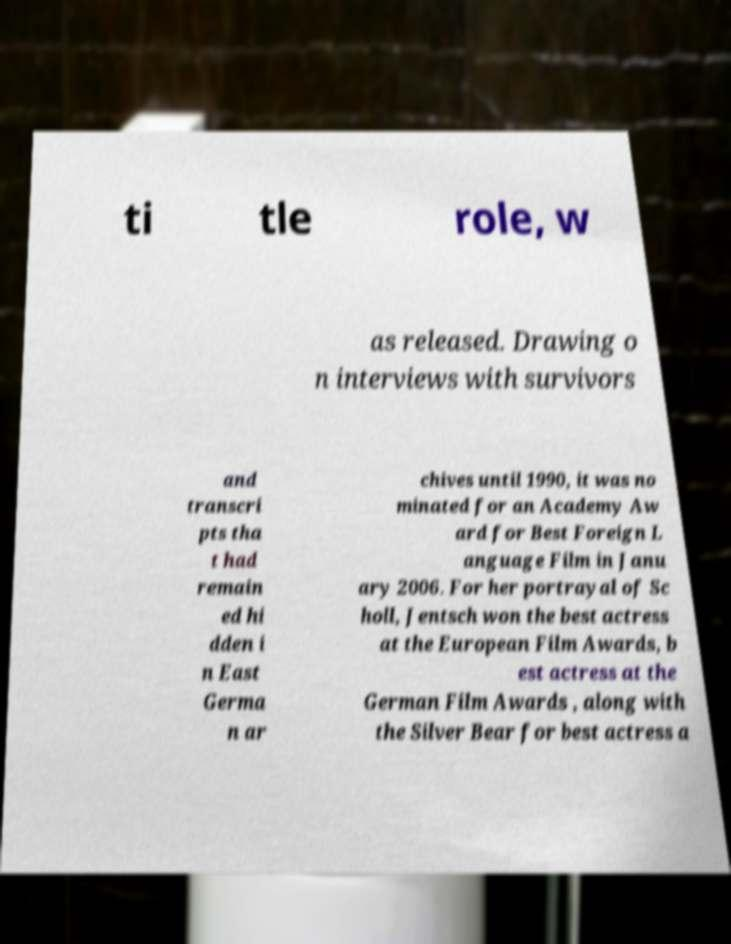Please identify and transcribe the text found in this image. ti tle role, w as released. Drawing o n interviews with survivors and transcri pts tha t had remain ed hi dden i n East Germa n ar chives until 1990, it was no minated for an Academy Aw ard for Best Foreign L anguage Film in Janu ary 2006. For her portrayal of Sc holl, Jentsch won the best actress at the European Film Awards, b est actress at the German Film Awards , along with the Silver Bear for best actress a 